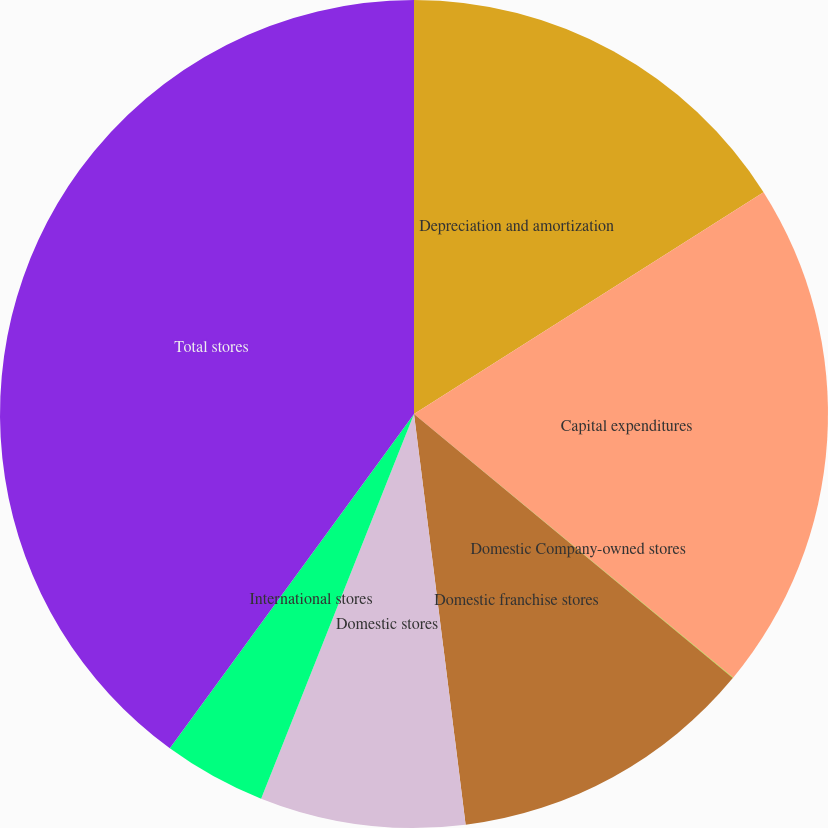Convert chart. <chart><loc_0><loc_0><loc_500><loc_500><pie_chart><fcel>Depreciation and amortization<fcel>Capital expenditures<fcel>Domestic Company-owned stores<fcel>Domestic franchise stores<fcel>Domestic stores<fcel>International stores<fcel>Total stores<nl><fcel>16.0%<fcel>19.99%<fcel>0.02%<fcel>12.0%<fcel>8.01%<fcel>4.02%<fcel>39.96%<nl></chart> 